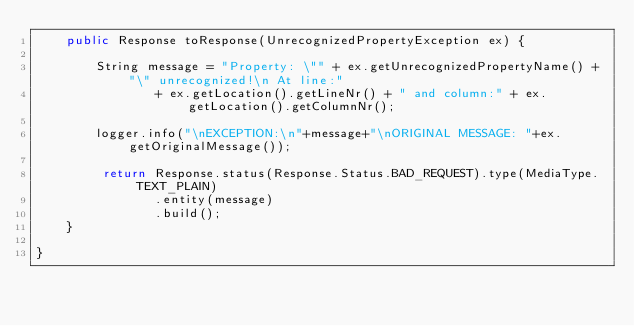<code> <loc_0><loc_0><loc_500><loc_500><_Java_>	public Response toResponse(UnrecognizedPropertyException ex) {
		
		String message = "Property: \"" + ex.getUnrecognizedPropertyName() + "\" unrecognized!\n At line:"
				+ ex.getLocation().getLineNr() + " and column:" + ex.getLocation().getColumnNr();
		
		logger.info("\nEXCEPTION:\n"+message+"\nORIGINAL MESSAGE: "+ex.getOriginalMessage());
		
		 return Response.status(Response.Status.BAD_REQUEST).type(MediaType.TEXT_PLAIN)
				.entity(message)
				.build();
	}

}
</code> 